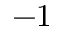Convert formula to latex. <formula><loc_0><loc_0><loc_500><loc_500>- 1</formula> 